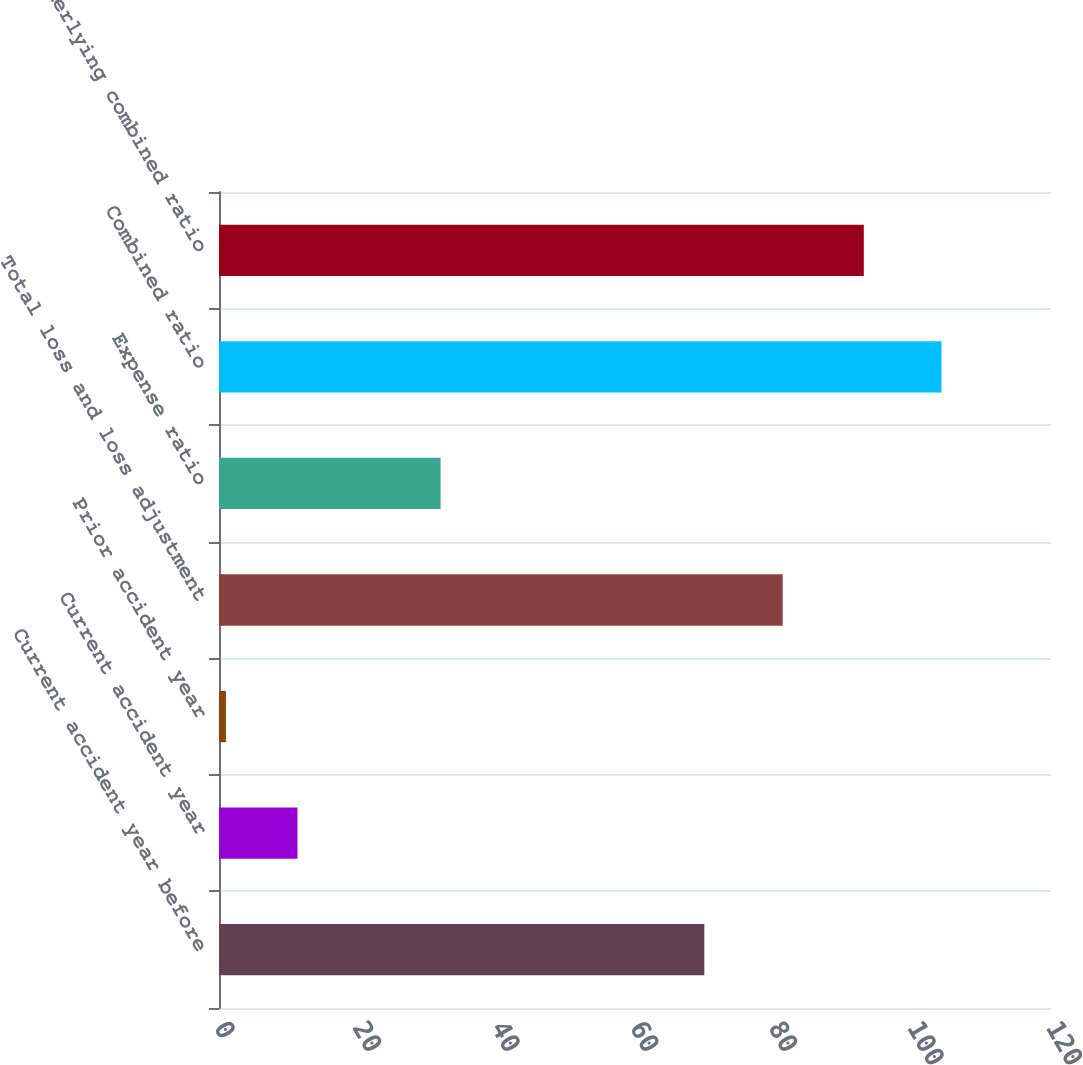Convert chart to OTSL. <chart><loc_0><loc_0><loc_500><loc_500><bar_chart><fcel>Current accident year before<fcel>Current accident year<fcel>Prior accident year<fcel>Total loss and loss adjustment<fcel>Expense ratio<fcel>Combined ratio<fcel>Underlying combined ratio<nl><fcel>70<fcel>11.32<fcel>1<fcel>81.3<fcel>31.96<fcel>104.2<fcel>93<nl></chart> 